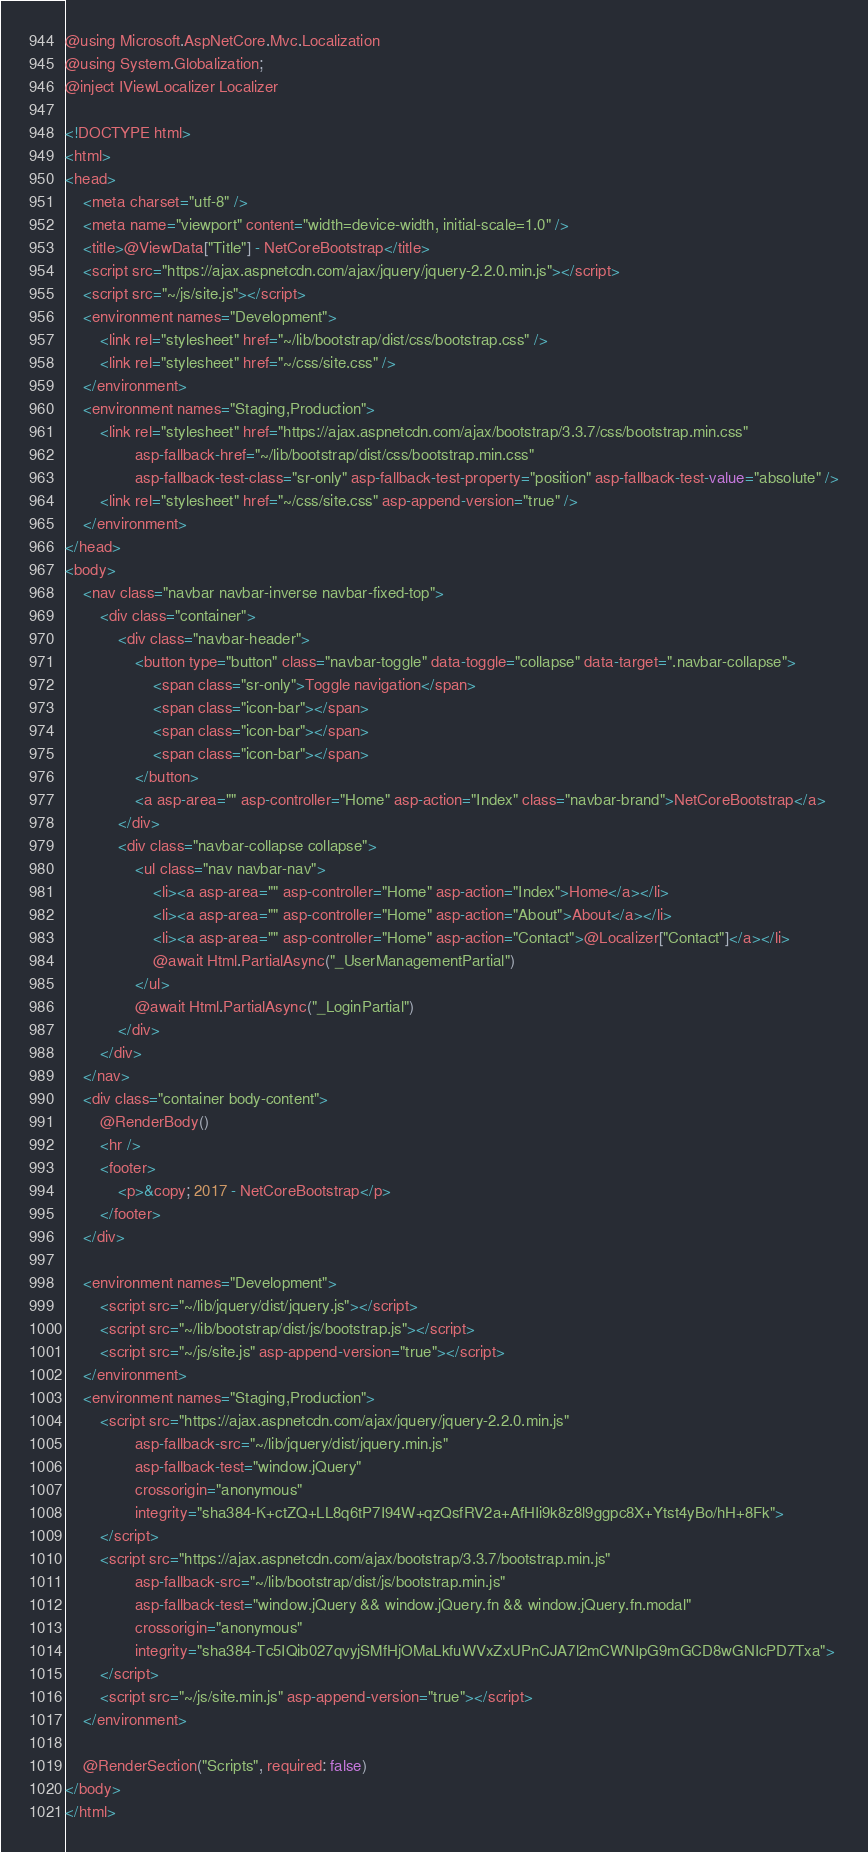<code> <loc_0><loc_0><loc_500><loc_500><_C#_>@using Microsoft.AspNetCore.Mvc.Localization
@using System.Globalization;
@inject IViewLocalizer Localizer

<!DOCTYPE html>
<html>
<head>
    <meta charset="utf-8" />
    <meta name="viewport" content="width=device-width, initial-scale=1.0" />
    <title>@ViewData["Title"] - NetCoreBootstrap</title>
    <script src="https://ajax.aspnetcdn.com/ajax/jquery/jquery-2.2.0.min.js"></script>
    <script src="~/js/site.js"></script>
    <environment names="Development">
        <link rel="stylesheet" href="~/lib/bootstrap/dist/css/bootstrap.css" />
        <link rel="stylesheet" href="~/css/site.css" />
    </environment>
    <environment names="Staging,Production">
        <link rel="stylesheet" href="https://ajax.aspnetcdn.com/ajax/bootstrap/3.3.7/css/bootstrap.min.css"
                asp-fallback-href="~/lib/bootstrap/dist/css/bootstrap.min.css"
                asp-fallback-test-class="sr-only" asp-fallback-test-property="position" asp-fallback-test-value="absolute" />
        <link rel="stylesheet" href="~/css/site.css" asp-append-version="true" />
    </environment>
</head>
<body>
    <nav class="navbar navbar-inverse navbar-fixed-top">
        <div class="container">
            <div class="navbar-header">
                <button type="button" class="navbar-toggle" data-toggle="collapse" data-target=".navbar-collapse">
                    <span class="sr-only">Toggle navigation</span>
                    <span class="icon-bar"></span>
                    <span class="icon-bar"></span>
                    <span class="icon-bar"></span>
                </button>
                <a asp-area="" asp-controller="Home" asp-action="Index" class="navbar-brand">NetCoreBootstrap</a>
            </div>
            <div class="navbar-collapse collapse">
                <ul class="nav navbar-nav">
                    <li><a asp-area="" asp-controller="Home" asp-action="Index">Home</a></li>
                    <li><a asp-area="" asp-controller="Home" asp-action="About">About</a></li>
                    <li><a asp-area="" asp-controller="Home" asp-action="Contact">@Localizer["Contact"]</a></li>
                    @await Html.PartialAsync("_UserManagementPartial")
                </ul>
                @await Html.PartialAsync("_LoginPartial")
            </div>
        </div>
    </nav>
    <div class="container body-content">
        @RenderBody()
        <hr />
        <footer>
            <p>&copy; 2017 - NetCoreBootstrap</p>
        </footer>
    </div>

    <environment names="Development">
        <script src="~/lib/jquery/dist/jquery.js"></script>
        <script src="~/lib/bootstrap/dist/js/bootstrap.js"></script>
        <script src="~/js/site.js" asp-append-version="true"></script>
    </environment>
    <environment names="Staging,Production">
        <script src="https://ajax.aspnetcdn.com/ajax/jquery/jquery-2.2.0.min.js"
                asp-fallback-src="~/lib/jquery/dist/jquery.min.js"
                asp-fallback-test="window.jQuery"
                crossorigin="anonymous"
                integrity="sha384-K+ctZQ+LL8q6tP7I94W+qzQsfRV2a+AfHIi9k8z8l9ggpc8X+Ytst4yBo/hH+8Fk">
        </script>
        <script src="https://ajax.aspnetcdn.com/ajax/bootstrap/3.3.7/bootstrap.min.js"
                asp-fallback-src="~/lib/bootstrap/dist/js/bootstrap.min.js"
                asp-fallback-test="window.jQuery && window.jQuery.fn && window.jQuery.fn.modal"
                crossorigin="anonymous"
                integrity="sha384-Tc5IQib027qvyjSMfHjOMaLkfuWVxZxUPnCJA7l2mCWNIpG9mGCD8wGNIcPD7Txa">
        </script>
        <script src="~/js/site.min.js" asp-append-version="true"></script>
    </environment>

    @RenderSection("Scripts", required: false)
</body>
</html>
</code> 